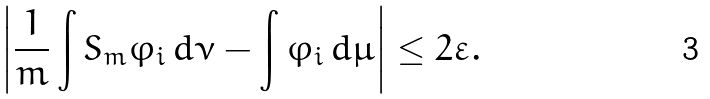Convert formula to latex. <formula><loc_0><loc_0><loc_500><loc_500>\left | \frac { 1 } { m } \int S _ { m } \varphi _ { i } \, d \nu - \int \varphi _ { i } \, d \mu \right | \leq 2 \varepsilon .</formula> 